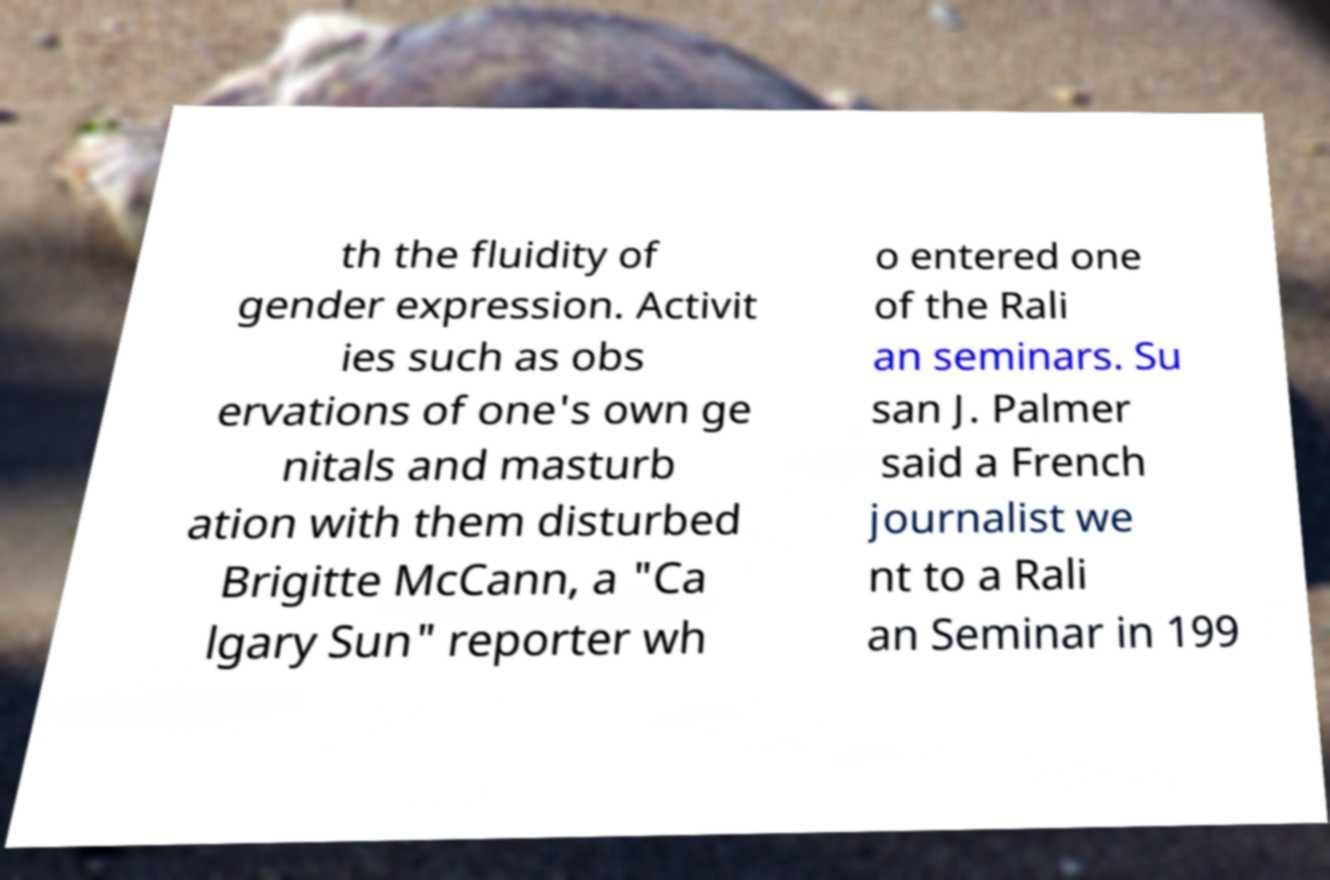There's text embedded in this image that I need extracted. Can you transcribe it verbatim? th the fluidity of gender expression. Activit ies such as obs ervations of one's own ge nitals and masturb ation with them disturbed Brigitte McCann, a "Ca lgary Sun" reporter wh o entered one of the Rali an seminars. Su san J. Palmer said a French journalist we nt to a Rali an Seminar in 199 